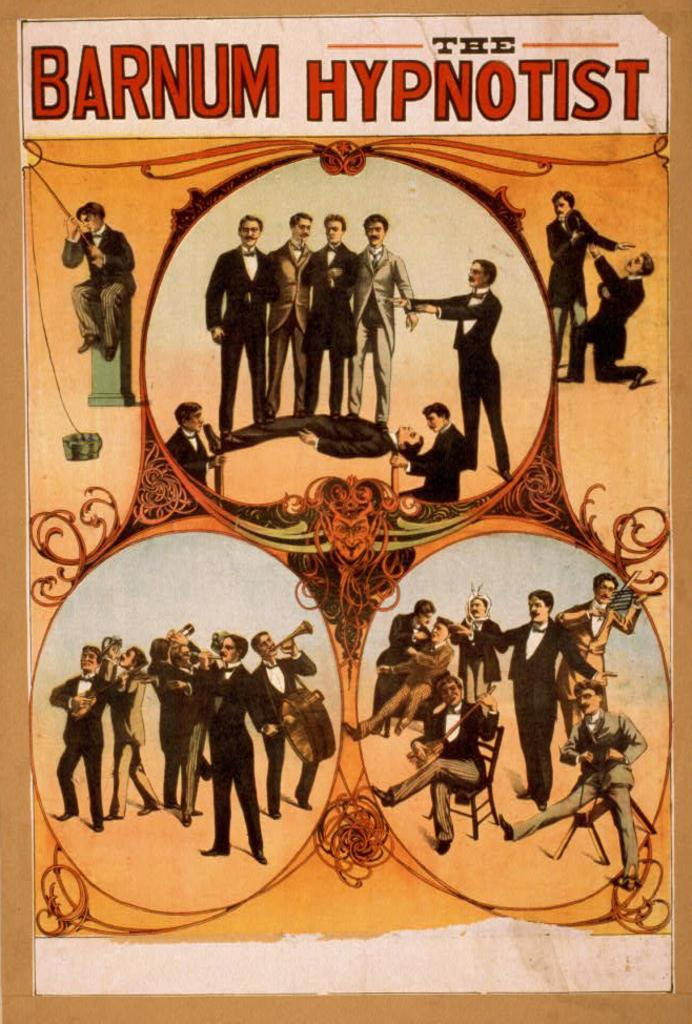<image>
Share a concise interpretation of the image provided. Poster showing people performing and says Barnum Hypnotist on top. 